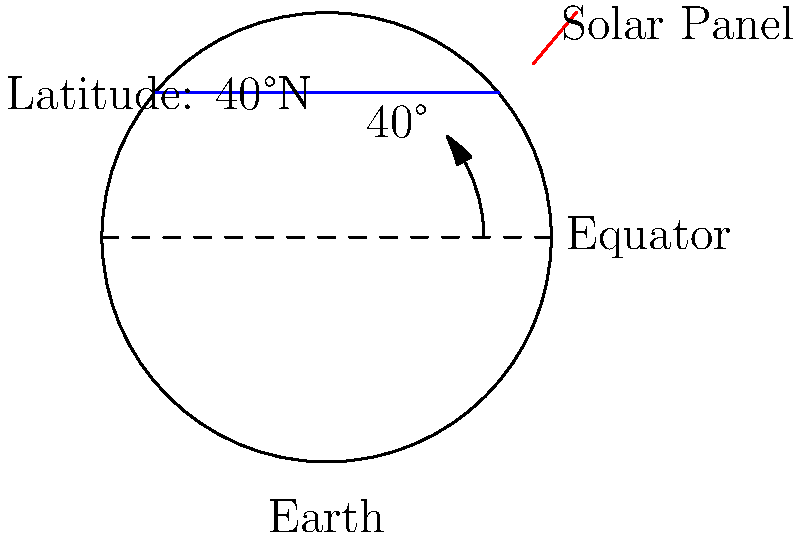As an investor looking to optimize the efficiency of solar panel installations, you need to determine the optimal tilt angle for a solar panel at a latitude of 40°N. Based on the general rule for fixed-tilt systems, what should be the tilt angle of the solar panel relative to the horizontal to maximize annual energy production? To determine the optimal tilt angle for a solar panel, we can follow these steps:

1. Understand the general rule: For fixed-tilt systems, the optimal tilt angle is approximately equal to the latitude of the location.

2. Identify the latitude: In this case, the latitude is given as 40°N.

3. Apply the rule: The optimal tilt angle should be equal to the latitude, which is 40°.

4. Consider the angle relative to horizontal: The question asks for the tilt angle relative to the horizontal, which is already what we've calculated.

5. Verify with the diagram: The diagram shows the Earth and a solar panel at 40°N latitude. The panel is drawn perpendicular to the incoming solar radiation, which corresponds to a tilt angle equal to the latitude.

6. Additional consideration: While this rule provides a good approximation for maximizing annual energy production, it's worth noting that slight adjustments might be made based on local climate conditions or seasonal preferences. However, for general purposes and this question, we stick to the basic rule.

Therefore, the optimal tilt angle for the solar panel at 40°N latitude is 40° relative to the horizontal.
Answer: 40° 